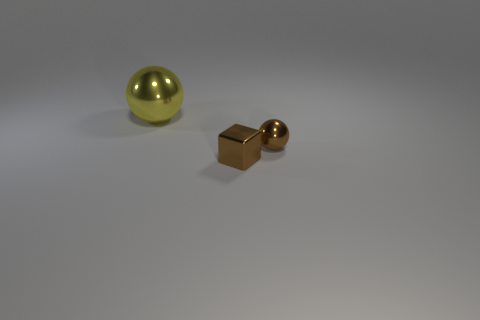Add 1 tiny cyan rubber balls. How many objects exist? 4 Subtract all blocks. How many objects are left? 2 Subtract 0 red cylinders. How many objects are left? 3 Subtract 1 blocks. How many blocks are left? 0 Subtract all blue cubes. Subtract all yellow cylinders. How many cubes are left? 1 Subtract all yellow cylinders. How many yellow balls are left? 1 Subtract all brown shiny spheres. Subtract all small brown cubes. How many objects are left? 1 Add 2 tiny brown spheres. How many tiny brown spheres are left? 3 Add 1 gray objects. How many gray objects exist? 1 